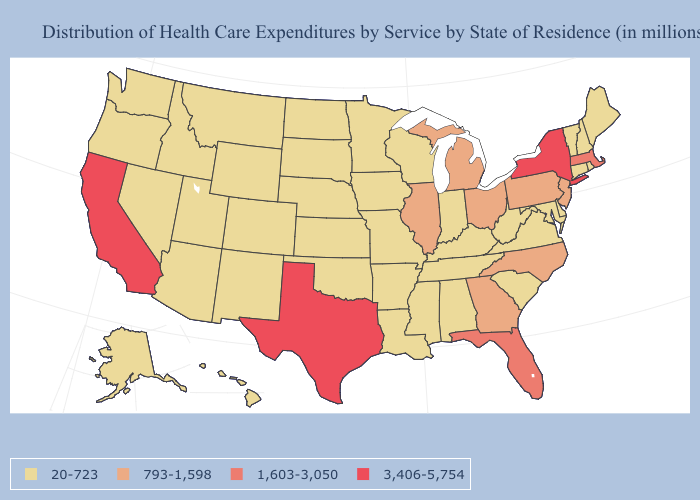What is the highest value in states that border Texas?
Short answer required. 20-723. What is the value of Oklahoma?
Give a very brief answer. 20-723. Name the states that have a value in the range 1,603-3,050?
Keep it brief. Florida, Massachusetts. What is the value of West Virginia?
Be succinct. 20-723. Name the states that have a value in the range 20-723?
Give a very brief answer. Alabama, Alaska, Arizona, Arkansas, Colorado, Connecticut, Delaware, Hawaii, Idaho, Indiana, Iowa, Kansas, Kentucky, Louisiana, Maine, Maryland, Minnesota, Mississippi, Missouri, Montana, Nebraska, Nevada, New Hampshire, New Mexico, North Dakota, Oklahoma, Oregon, Rhode Island, South Carolina, South Dakota, Tennessee, Utah, Vermont, Virginia, Washington, West Virginia, Wisconsin, Wyoming. What is the value of Michigan?
Concise answer only. 793-1,598. Does New York have the highest value in the Northeast?
Answer briefly. Yes. Does the map have missing data?
Be succinct. No. How many symbols are there in the legend?
Keep it brief. 4. Among the states that border Ohio , does West Virginia have the highest value?
Keep it brief. No. Name the states that have a value in the range 793-1,598?
Answer briefly. Georgia, Illinois, Michigan, New Jersey, North Carolina, Ohio, Pennsylvania. Does Indiana have a lower value than California?
Concise answer only. Yes. Does Florida have the same value as Massachusetts?
Answer briefly. Yes. Does Utah have a lower value than North Carolina?
Quick response, please. Yes. What is the value of West Virginia?
Short answer required. 20-723. 